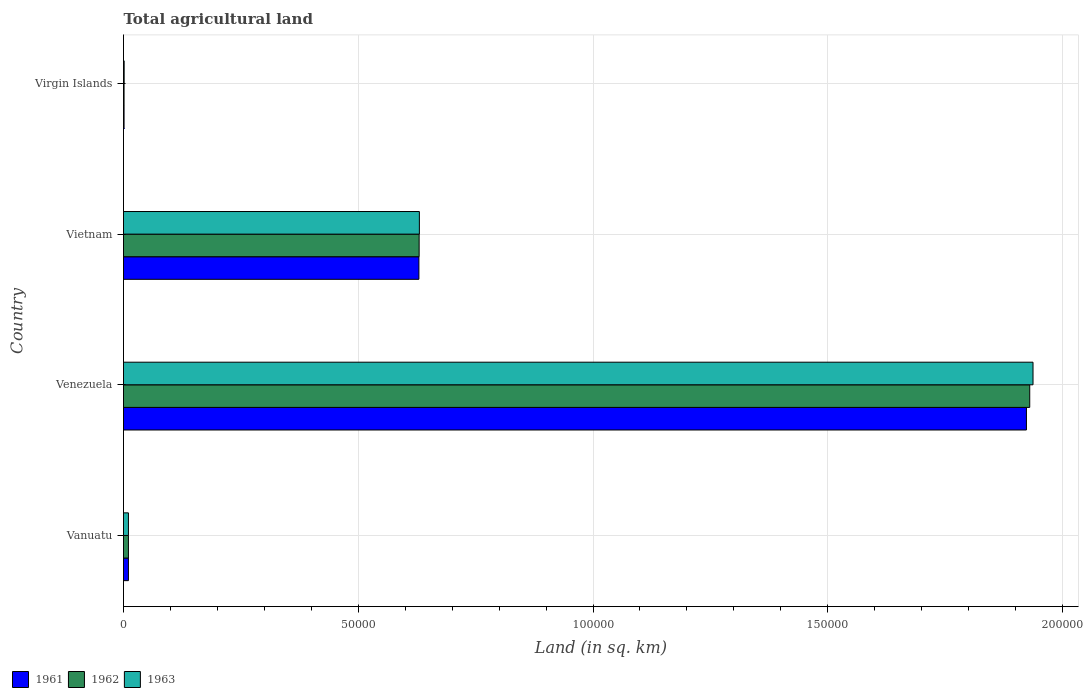How many groups of bars are there?
Your answer should be very brief. 4. Are the number of bars per tick equal to the number of legend labels?
Your answer should be compact. Yes. What is the label of the 4th group of bars from the top?
Provide a short and direct response. Vanuatu. In how many cases, is the number of bars for a given country not equal to the number of legend labels?
Your answer should be very brief. 0. What is the total agricultural land in 1962 in Vanuatu?
Offer a terse response. 1050. Across all countries, what is the maximum total agricultural land in 1961?
Provide a short and direct response. 1.92e+05. Across all countries, what is the minimum total agricultural land in 1962?
Offer a terse response. 120. In which country was the total agricultural land in 1962 maximum?
Offer a terse response. Venezuela. In which country was the total agricultural land in 1962 minimum?
Provide a short and direct response. Virgin Islands. What is the total total agricultural land in 1963 in the graph?
Ensure brevity in your answer.  2.58e+05. What is the difference between the total agricultural land in 1963 in Vanuatu and that in Vietnam?
Ensure brevity in your answer.  -6.20e+04. What is the difference between the total agricultural land in 1963 in Virgin Islands and the total agricultural land in 1962 in Vanuatu?
Provide a short and direct response. -910. What is the average total agricultural land in 1963 per country?
Make the answer very short. 6.45e+04. What is the difference between the total agricultural land in 1963 and total agricultural land in 1962 in Venezuela?
Offer a very short reply. 700. In how many countries, is the total agricultural land in 1962 greater than 40000 sq.km?
Your answer should be very brief. 2. What is the ratio of the total agricultural land in 1963 in Venezuela to that in Virgin Islands?
Make the answer very short. 1383.71. What is the difference between the highest and the second highest total agricultural land in 1961?
Provide a succinct answer. 1.29e+05. What is the difference between the highest and the lowest total agricultural land in 1963?
Provide a succinct answer. 1.94e+05. What does the 2nd bar from the top in Vietnam represents?
Offer a very short reply. 1962. How many bars are there?
Offer a very short reply. 12. Are all the bars in the graph horizontal?
Make the answer very short. Yes. Are the values on the major ticks of X-axis written in scientific E-notation?
Provide a short and direct response. No. Does the graph contain any zero values?
Keep it short and to the point. No. Does the graph contain grids?
Keep it short and to the point. Yes. How many legend labels are there?
Provide a short and direct response. 3. How are the legend labels stacked?
Keep it short and to the point. Horizontal. What is the title of the graph?
Your response must be concise. Total agricultural land. What is the label or title of the X-axis?
Your answer should be very brief. Land (in sq. km). What is the label or title of the Y-axis?
Give a very brief answer. Country. What is the Land (in sq. km) of 1961 in Vanuatu?
Make the answer very short. 1050. What is the Land (in sq. km) of 1962 in Vanuatu?
Ensure brevity in your answer.  1050. What is the Land (in sq. km) in 1963 in Vanuatu?
Ensure brevity in your answer.  1050. What is the Land (in sq. km) of 1961 in Venezuela?
Give a very brief answer. 1.92e+05. What is the Land (in sq. km) of 1962 in Venezuela?
Ensure brevity in your answer.  1.93e+05. What is the Land (in sq. km) of 1963 in Venezuela?
Your answer should be very brief. 1.94e+05. What is the Land (in sq. km) in 1961 in Vietnam?
Provide a succinct answer. 6.29e+04. What is the Land (in sq. km) in 1962 in Vietnam?
Your response must be concise. 6.30e+04. What is the Land (in sq. km) in 1963 in Vietnam?
Provide a short and direct response. 6.30e+04. What is the Land (in sq. km) of 1961 in Virgin Islands?
Make the answer very short. 120. What is the Land (in sq. km) of 1962 in Virgin Islands?
Keep it short and to the point. 120. What is the Land (in sq. km) of 1963 in Virgin Islands?
Provide a short and direct response. 140. Across all countries, what is the maximum Land (in sq. km) of 1961?
Your answer should be very brief. 1.92e+05. Across all countries, what is the maximum Land (in sq. km) of 1962?
Ensure brevity in your answer.  1.93e+05. Across all countries, what is the maximum Land (in sq. km) in 1963?
Your response must be concise. 1.94e+05. Across all countries, what is the minimum Land (in sq. km) of 1961?
Provide a short and direct response. 120. Across all countries, what is the minimum Land (in sq. km) in 1962?
Provide a short and direct response. 120. Across all countries, what is the minimum Land (in sq. km) of 1963?
Ensure brevity in your answer.  140. What is the total Land (in sq. km) in 1961 in the graph?
Your answer should be compact. 2.56e+05. What is the total Land (in sq. km) of 1962 in the graph?
Make the answer very short. 2.57e+05. What is the total Land (in sq. km) of 1963 in the graph?
Provide a short and direct response. 2.58e+05. What is the difference between the Land (in sq. km) of 1961 in Vanuatu and that in Venezuela?
Provide a short and direct response. -1.91e+05. What is the difference between the Land (in sq. km) in 1962 in Vanuatu and that in Venezuela?
Keep it short and to the point. -1.92e+05. What is the difference between the Land (in sq. km) of 1963 in Vanuatu and that in Venezuela?
Make the answer very short. -1.93e+05. What is the difference between the Land (in sq. km) of 1961 in Vanuatu and that in Vietnam?
Your response must be concise. -6.19e+04. What is the difference between the Land (in sq. km) of 1962 in Vanuatu and that in Vietnam?
Provide a succinct answer. -6.19e+04. What is the difference between the Land (in sq. km) of 1963 in Vanuatu and that in Vietnam?
Offer a very short reply. -6.20e+04. What is the difference between the Land (in sq. km) of 1961 in Vanuatu and that in Virgin Islands?
Your answer should be compact. 930. What is the difference between the Land (in sq. km) of 1962 in Vanuatu and that in Virgin Islands?
Make the answer very short. 930. What is the difference between the Land (in sq. km) of 1963 in Vanuatu and that in Virgin Islands?
Your answer should be very brief. 910. What is the difference between the Land (in sq. km) in 1961 in Venezuela and that in Vietnam?
Offer a very short reply. 1.29e+05. What is the difference between the Land (in sq. km) of 1962 in Venezuela and that in Vietnam?
Your answer should be compact. 1.30e+05. What is the difference between the Land (in sq. km) in 1963 in Venezuela and that in Vietnam?
Offer a very short reply. 1.31e+05. What is the difference between the Land (in sq. km) of 1961 in Venezuela and that in Virgin Islands?
Your response must be concise. 1.92e+05. What is the difference between the Land (in sq. km) of 1962 in Venezuela and that in Virgin Islands?
Make the answer very short. 1.93e+05. What is the difference between the Land (in sq. km) in 1963 in Venezuela and that in Virgin Islands?
Keep it short and to the point. 1.94e+05. What is the difference between the Land (in sq. km) of 1961 in Vietnam and that in Virgin Islands?
Ensure brevity in your answer.  6.28e+04. What is the difference between the Land (in sq. km) in 1962 in Vietnam and that in Virgin Islands?
Provide a succinct answer. 6.28e+04. What is the difference between the Land (in sq. km) in 1963 in Vietnam and that in Virgin Islands?
Provide a short and direct response. 6.29e+04. What is the difference between the Land (in sq. km) of 1961 in Vanuatu and the Land (in sq. km) of 1962 in Venezuela?
Ensure brevity in your answer.  -1.92e+05. What is the difference between the Land (in sq. km) of 1961 in Vanuatu and the Land (in sq. km) of 1963 in Venezuela?
Provide a succinct answer. -1.93e+05. What is the difference between the Land (in sq. km) of 1962 in Vanuatu and the Land (in sq. km) of 1963 in Venezuela?
Your answer should be compact. -1.93e+05. What is the difference between the Land (in sq. km) of 1961 in Vanuatu and the Land (in sq. km) of 1962 in Vietnam?
Make the answer very short. -6.19e+04. What is the difference between the Land (in sq. km) in 1961 in Vanuatu and the Land (in sq. km) in 1963 in Vietnam?
Provide a succinct answer. -6.20e+04. What is the difference between the Land (in sq. km) in 1962 in Vanuatu and the Land (in sq. km) in 1963 in Vietnam?
Your answer should be very brief. -6.20e+04. What is the difference between the Land (in sq. km) of 1961 in Vanuatu and the Land (in sq. km) of 1962 in Virgin Islands?
Offer a very short reply. 930. What is the difference between the Land (in sq. km) of 1961 in Vanuatu and the Land (in sq. km) of 1963 in Virgin Islands?
Make the answer very short. 910. What is the difference between the Land (in sq. km) of 1962 in Vanuatu and the Land (in sq. km) of 1963 in Virgin Islands?
Offer a terse response. 910. What is the difference between the Land (in sq. km) in 1961 in Venezuela and the Land (in sq. km) in 1962 in Vietnam?
Your answer should be very brief. 1.29e+05. What is the difference between the Land (in sq. km) of 1961 in Venezuela and the Land (in sq. km) of 1963 in Vietnam?
Keep it short and to the point. 1.29e+05. What is the difference between the Land (in sq. km) of 1961 in Venezuela and the Land (in sq. km) of 1962 in Virgin Islands?
Make the answer very short. 1.92e+05. What is the difference between the Land (in sq. km) of 1961 in Venezuela and the Land (in sq. km) of 1963 in Virgin Islands?
Ensure brevity in your answer.  1.92e+05. What is the difference between the Land (in sq. km) of 1962 in Venezuela and the Land (in sq. km) of 1963 in Virgin Islands?
Your answer should be very brief. 1.93e+05. What is the difference between the Land (in sq. km) in 1961 in Vietnam and the Land (in sq. km) in 1962 in Virgin Islands?
Give a very brief answer. 6.28e+04. What is the difference between the Land (in sq. km) in 1961 in Vietnam and the Land (in sq. km) in 1963 in Virgin Islands?
Your answer should be compact. 6.28e+04. What is the difference between the Land (in sq. km) of 1962 in Vietnam and the Land (in sq. km) of 1963 in Virgin Islands?
Provide a succinct answer. 6.28e+04. What is the average Land (in sq. km) of 1961 per country?
Provide a short and direct response. 6.41e+04. What is the average Land (in sq. km) in 1962 per country?
Offer a terse response. 6.43e+04. What is the average Land (in sq. km) of 1963 per country?
Your response must be concise. 6.45e+04. What is the difference between the Land (in sq. km) in 1961 and Land (in sq. km) in 1962 in Vanuatu?
Offer a terse response. 0. What is the difference between the Land (in sq. km) of 1961 and Land (in sq. km) of 1962 in Venezuela?
Offer a terse response. -700. What is the difference between the Land (in sq. km) in 1961 and Land (in sq. km) in 1963 in Venezuela?
Offer a terse response. -1400. What is the difference between the Land (in sq. km) of 1962 and Land (in sq. km) of 1963 in Venezuela?
Give a very brief answer. -700. What is the difference between the Land (in sq. km) in 1961 and Land (in sq. km) in 1962 in Vietnam?
Your answer should be very brief. -50. What is the difference between the Land (in sq. km) of 1961 and Land (in sq. km) of 1963 in Vietnam?
Keep it short and to the point. -100. What is the difference between the Land (in sq. km) in 1961 and Land (in sq. km) in 1963 in Virgin Islands?
Offer a terse response. -20. What is the difference between the Land (in sq. km) in 1962 and Land (in sq. km) in 1963 in Virgin Islands?
Make the answer very short. -20. What is the ratio of the Land (in sq. km) of 1961 in Vanuatu to that in Venezuela?
Offer a terse response. 0.01. What is the ratio of the Land (in sq. km) in 1962 in Vanuatu to that in Venezuela?
Your answer should be compact. 0.01. What is the ratio of the Land (in sq. km) in 1963 in Vanuatu to that in Venezuela?
Give a very brief answer. 0.01. What is the ratio of the Land (in sq. km) of 1961 in Vanuatu to that in Vietnam?
Provide a succinct answer. 0.02. What is the ratio of the Land (in sq. km) in 1962 in Vanuatu to that in Vietnam?
Offer a terse response. 0.02. What is the ratio of the Land (in sq. km) of 1963 in Vanuatu to that in Vietnam?
Provide a short and direct response. 0.02. What is the ratio of the Land (in sq. km) of 1961 in Vanuatu to that in Virgin Islands?
Your answer should be very brief. 8.75. What is the ratio of the Land (in sq. km) of 1962 in Vanuatu to that in Virgin Islands?
Provide a short and direct response. 8.75. What is the ratio of the Land (in sq. km) of 1963 in Vanuatu to that in Virgin Islands?
Provide a short and direct response. 7.5. What is the ratio of the Land (in sq. km) in 1961 in Venezuela to that in Vietnam?
Provide a short and direct response. 3.06. What is the ratio of the Land (in sq. km) in 1962 in Venezuela to that in Vietnam?
Ensure brevity in your answer.  3.07. What is the ratio of the Land (in sq. km) of 1963 in Venezuela to that in Vietnam?
Your response must be concise. 3.07. What is the ratio of the Land (in sq. km) in 1961 in Venezuela to that in Virgin Islands?
Provide a succinct answer. 1602.67. What is the ratio of the Land (in sq. km) of 1962 in Venezuela to that in Virgin Islands?
Provide a succinct answer. 1608.5. What is the ratio of the Land (in sq. km) of 1963 in Venezuela to that in Virgin Islands?
Give a very brief answer. 1383.71. What is the ratio of the Land (in sq. km) of 1961 in Vietnam to that in Virgin Islands?
Keep it short and to the point. 524.33. What is the ratio of the Land (in sq. km) in 1962 in Vietnam to that in Virgin Islands?
Keep it short and to the point. 524.75. What is the ratio of the Land (in sq. km) in 1963 in Vietnam to that in Virgin Islands?
Offer a very short reply. 450.14. What is the difference between the highest and the second highest Land (in sq. km) in 1961?
Your response must be concise. 1.29e+05. What is the difference between the highest and the second highest Land (in sq. km) of 1962?
Offer a very short reply. 1.30e+05. What is the difference between the highest and the second highest Land (in sq. km) in 1963?
Keep it short and to the point. 1.31e+05. What is the difference between the highest and the lowest Land (in sq. km) in 1961?
Give a very brief answer. 1.92e+05. What is the difference between the highest and the lowest Land (in sq. km) of 1962?
Your answer should be compact. 1.93e+05. What is the difference between the highest and the lowest Land (in sq. km) in 1963?
Give a very brief answer. 1.94e+05. 